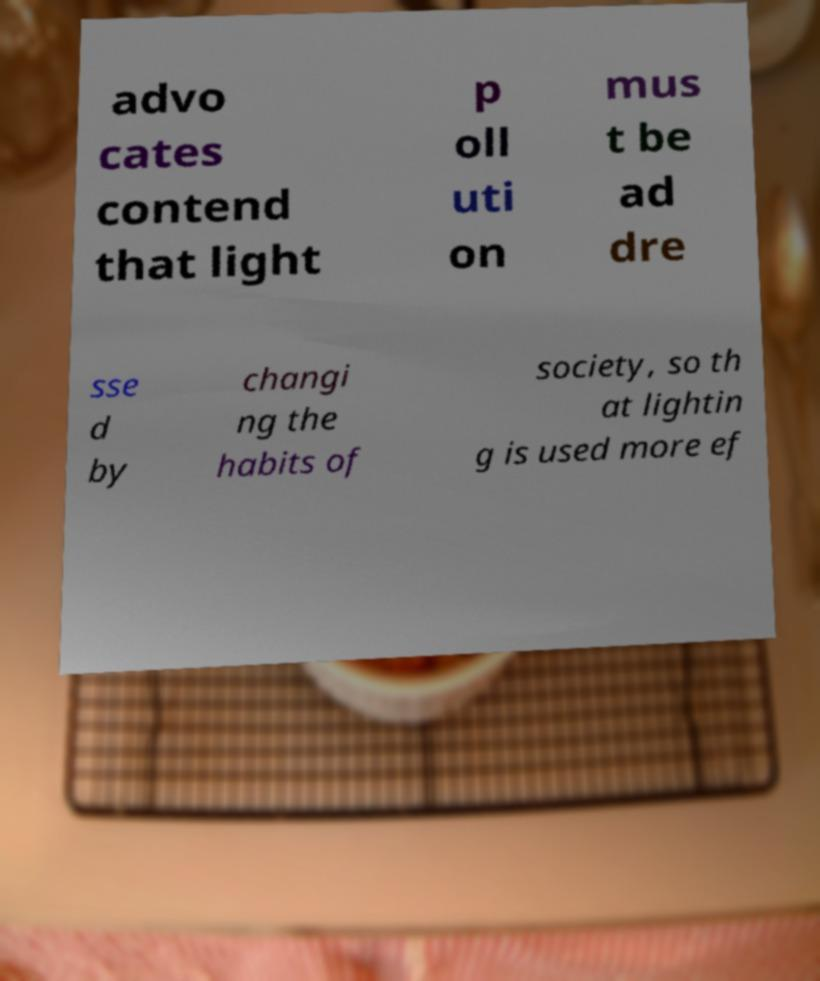Please read and relay the text visible in this image. What does it say? advo cates contend that light p oll uti on mus t be ad dre sse d by changi ng the habits of society, so th at lightin g is used more ef 